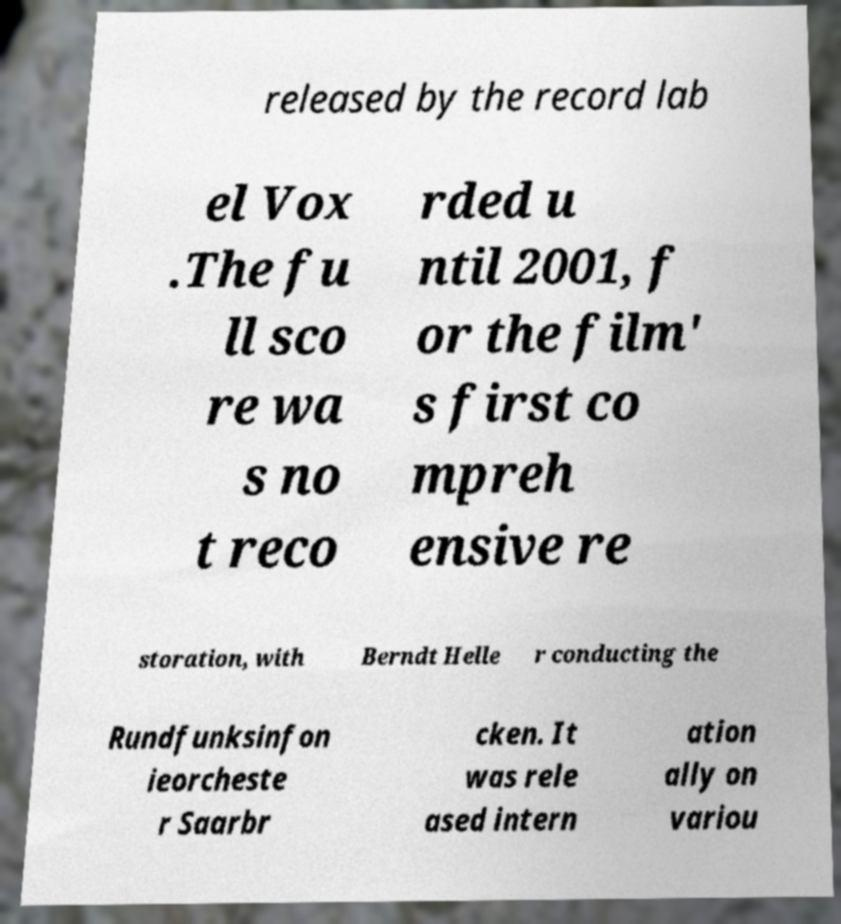Can you read and provide the text displayed in the image?This photo seems to have some interesting text. Can you extract and type it out for me? released by the record lab el Vox .The fu ll sco re wa s no t reco rded u ntil 2001, f or the film' s first co mpreh ensive re storation, with Berndt Helle r conducting the Rundfunksinfon ieorcheste r Saarbr cken. It was rele ased intern ation ally on variou 